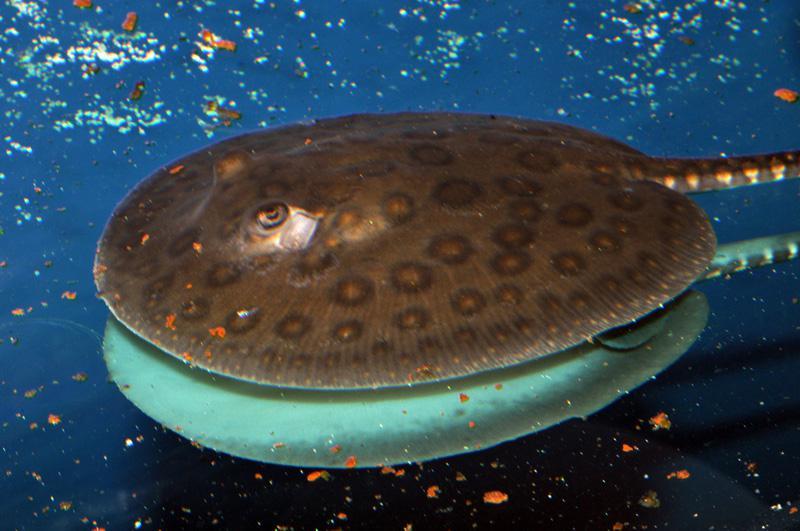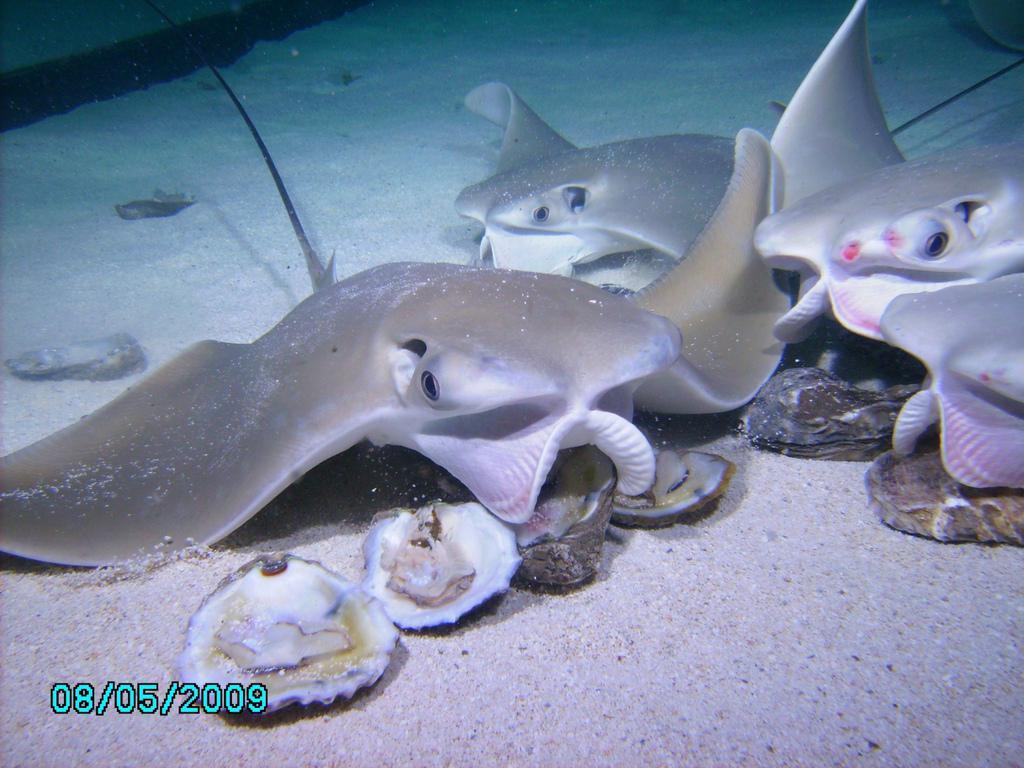The first image is the image on the left, the second image is the image on the right. Analyze the images presented: Is the assertion "In exactly one of the images a stingray is eating clams." valid? Answer yes or no. Yes. The first image is the image on the left, the second image is the image on the right. For the images shown, is this caption "One image appears to show one stingray on top of another stingray, and the other image shows at least one stingray positioned over oyster-like shells." true? Answer yes or no. Yes. 